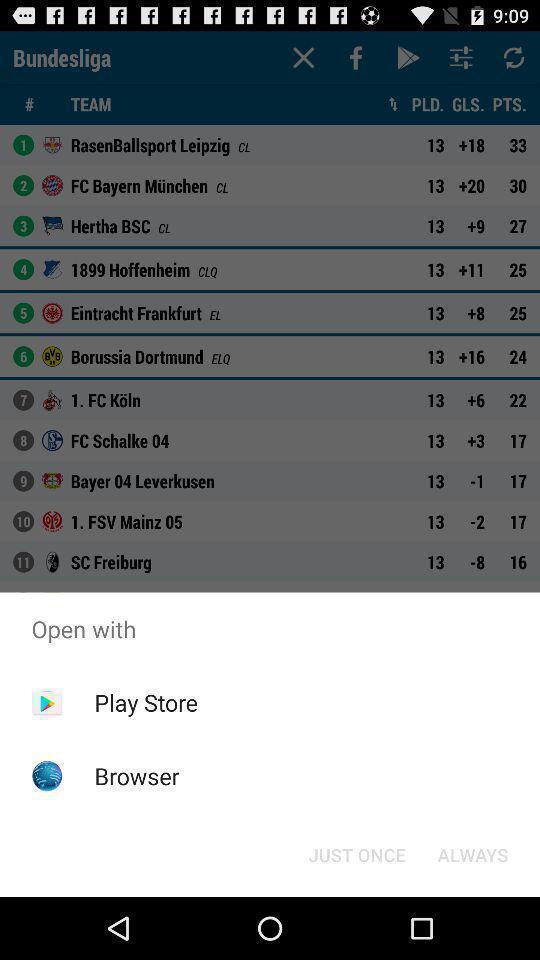What can you discern from this picture? Push up page showing app preference to open. 